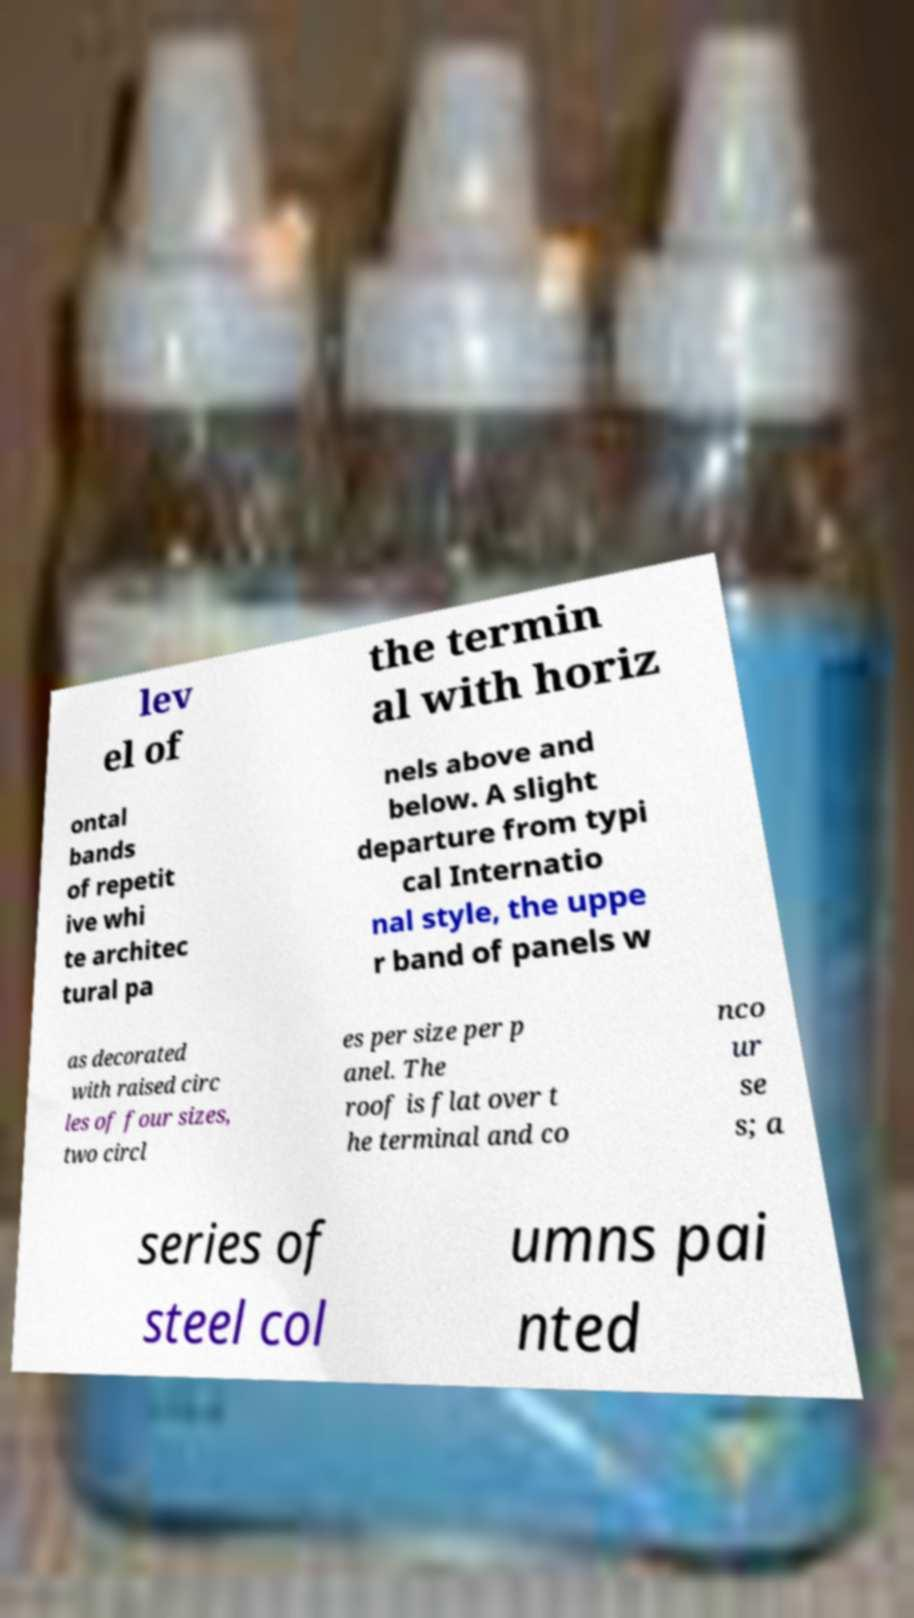Can you read and provide the text displayed in the image?This photo seems to have some interesting text. Can you extract and type it out for me? lev el of the termin al with horiz ontal bands of repetit ive whi te architec tural pa nels above and below. A slight departure from typi cal Internatio nal style, the uppe r band of panels w as decorated with raised circ les of four sizes, two circl es per size per p anel. The roof is flat over t he terminal and co nco ur se s; a series of steel col umns pai nted 